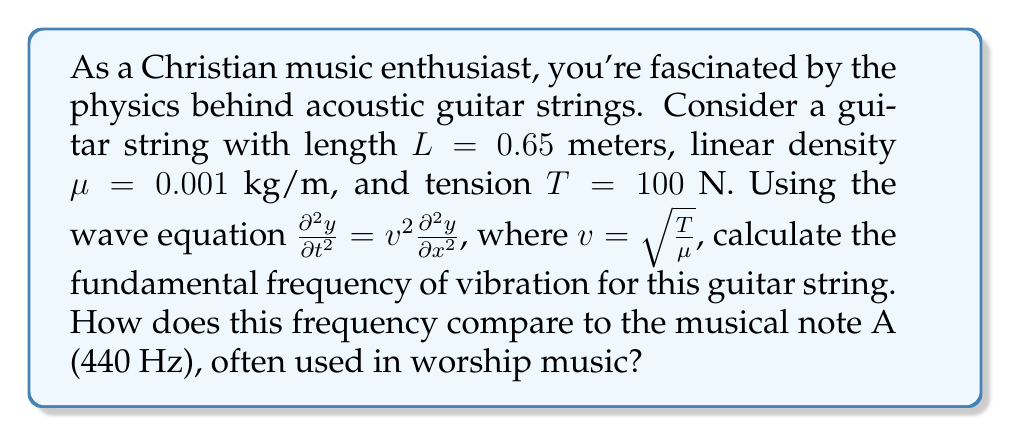Teach me how to tackle this problem. To solve this problem, we'll follow these steps:

1) First, we need to find the wave speed $v$ using the given formula:

   $v = \sqrt{\frac{T}{\mu}} = \sqrt{\frac{100}{0.001}} = 316.23$ m/s

2) The wave equation for a vibrating string is:

   $$\frac{\partial^2 y}{\partial t^2} = v^2 \frac{\partial^2 y}{\partial x^2}$$

3) The general solution for this equation, considering the fixed ends of the string, is:

   $$y(x,t) = \sin(\frac{n\pi x}{L}) \cos(\frac{n\pi v t}{L})$$

   where $n$ is the mode number (1 for fundamental frequency).

4) The frequency $f$ is related to the angular frequency $\omega$ by:

   $f = \frac{\omega}{2\pi}$

5) From the cosine term in the general solution, we can see that:

   $\omega = \frac{n\pi v}{L}$

6) Therefore, the fundamental frequency $(n=1)$ is:

   $$f = \frac{v}{2L} = \frac{316.23}{2(0.65)} = 243.25$$ Hz

7) Comparing to A (440 Hz):
   
   $\frac{243.25}{440} \approx 0.5528$

   This is close to $\frac{5}{9} \approx 0.5556$, which is the ratio between A3 (220 Hz) and A4 (440 Hz).
Answer: The fundamental frequency of the guitar string is approximately 243.25 Hz. This frequency is about half an octave below A4 (440 Hz), placing it close to the note B3 on the musical scale. 